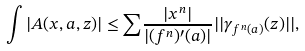<formula> <loc_0><loc_0><loc_500><loc_500>\int | A ( x , a , z ) | \leq { \sum } \frac { | x ^ { n } | } { | ( f ^ { n } ) ^ { \prime } ( a ) | } | | { \gamma } _ { f ^ { n } ( a ) } ( z ) | | ,</formula> 